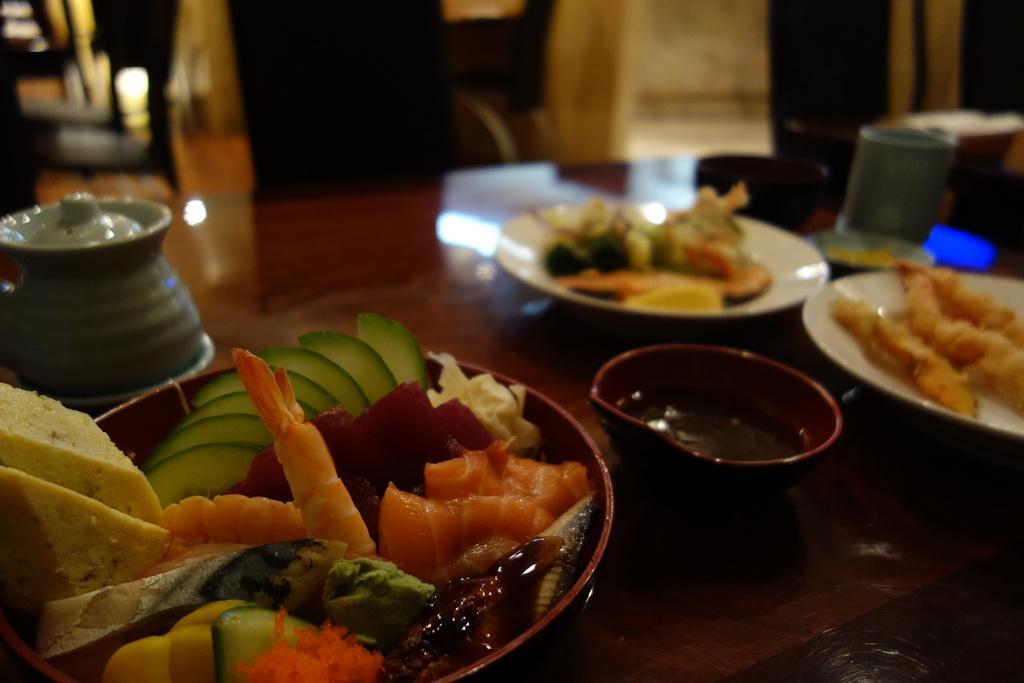In one or two sentences, can you explain what this image depicts? In this picture, we see a brown table on which a bowl containing sauce, a bowl containing fruits and eatables, plates with food and a jar are placed. Behind that, there are chairs and it is blurred in the background. 